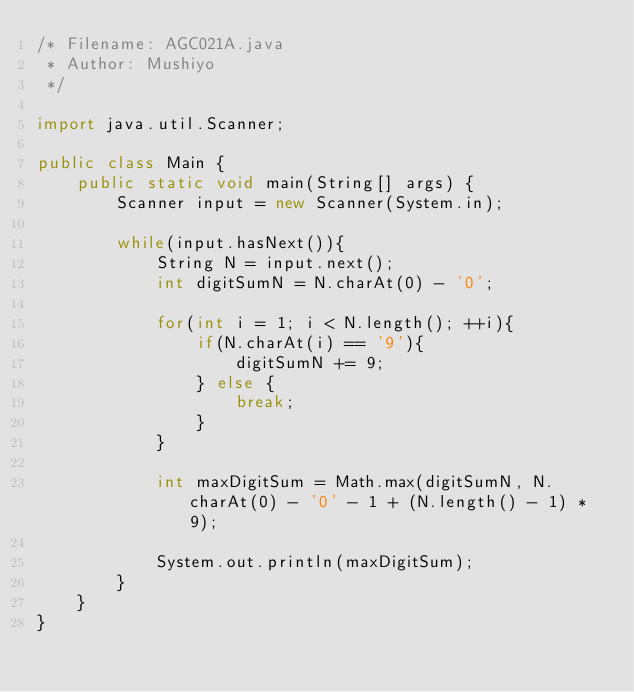<code> <loc_0><loc_0><loc_500><loc_500><_Java_>/* Filename: AGC021A.java
 * Author: Mushiyo
 */

import java.util.Scanner;

public class Main {
	public static void main(String[] args) {
		Scanner input = new Scanner(System.in);
		
		while(input.hasNext()){
			String N = input.next();
			int digitSumN = N.charAt(0) - '0';
			
			for(int i = 1; i < N.length(); ++i){
				if(N.charAt(i) == '9'){
					digitSumN += 9;
				} else {
					break;
				}
			}
			
			int maxDigitSum = Math.max(digitSumN, N.charAt(0) - '0' - 1 + (N.length() - 1) * 9);
			
			System.out.println(maxDigitSum);
		}
	}
}</code> 